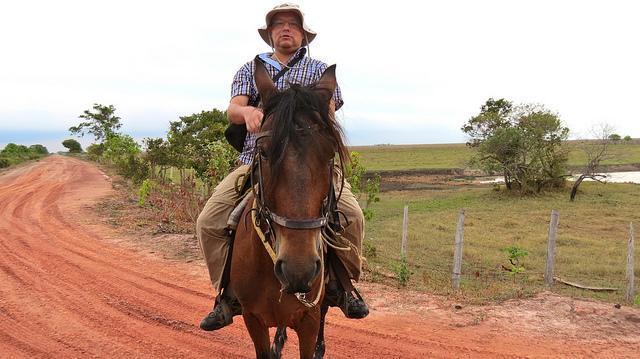How many cows are there?
Give a very brief answer. 0. 